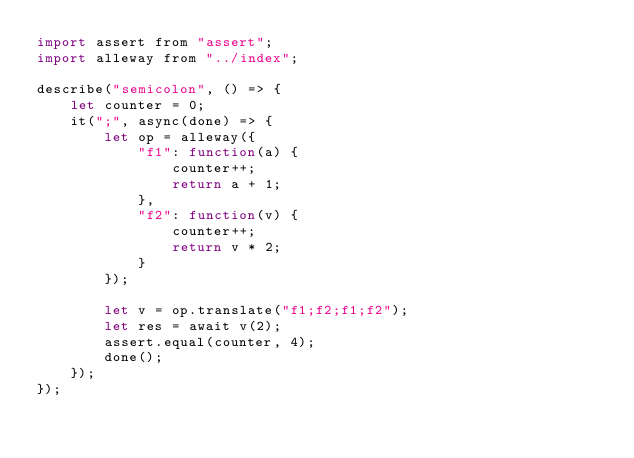<code> <loc_0><loc_0><loc_500><loc_500><_JavaScript_>import assert from "assert";
import alleway from "../index";

describe("semicolon", () => {
    let counter = 0;
    it(";", async(done) => {
        let op = alleway({
            "f1": function(a) {
                counter++;
                return a + 1;
            },
            "f2": function(v) {
                counter++;
                return v * 2;
            }
        });

        let v = op.translate("f1;f2;f1;f2");
        let res = await v(2);
        assert.equal(counter, 4);
        done();
    });
});</code> 